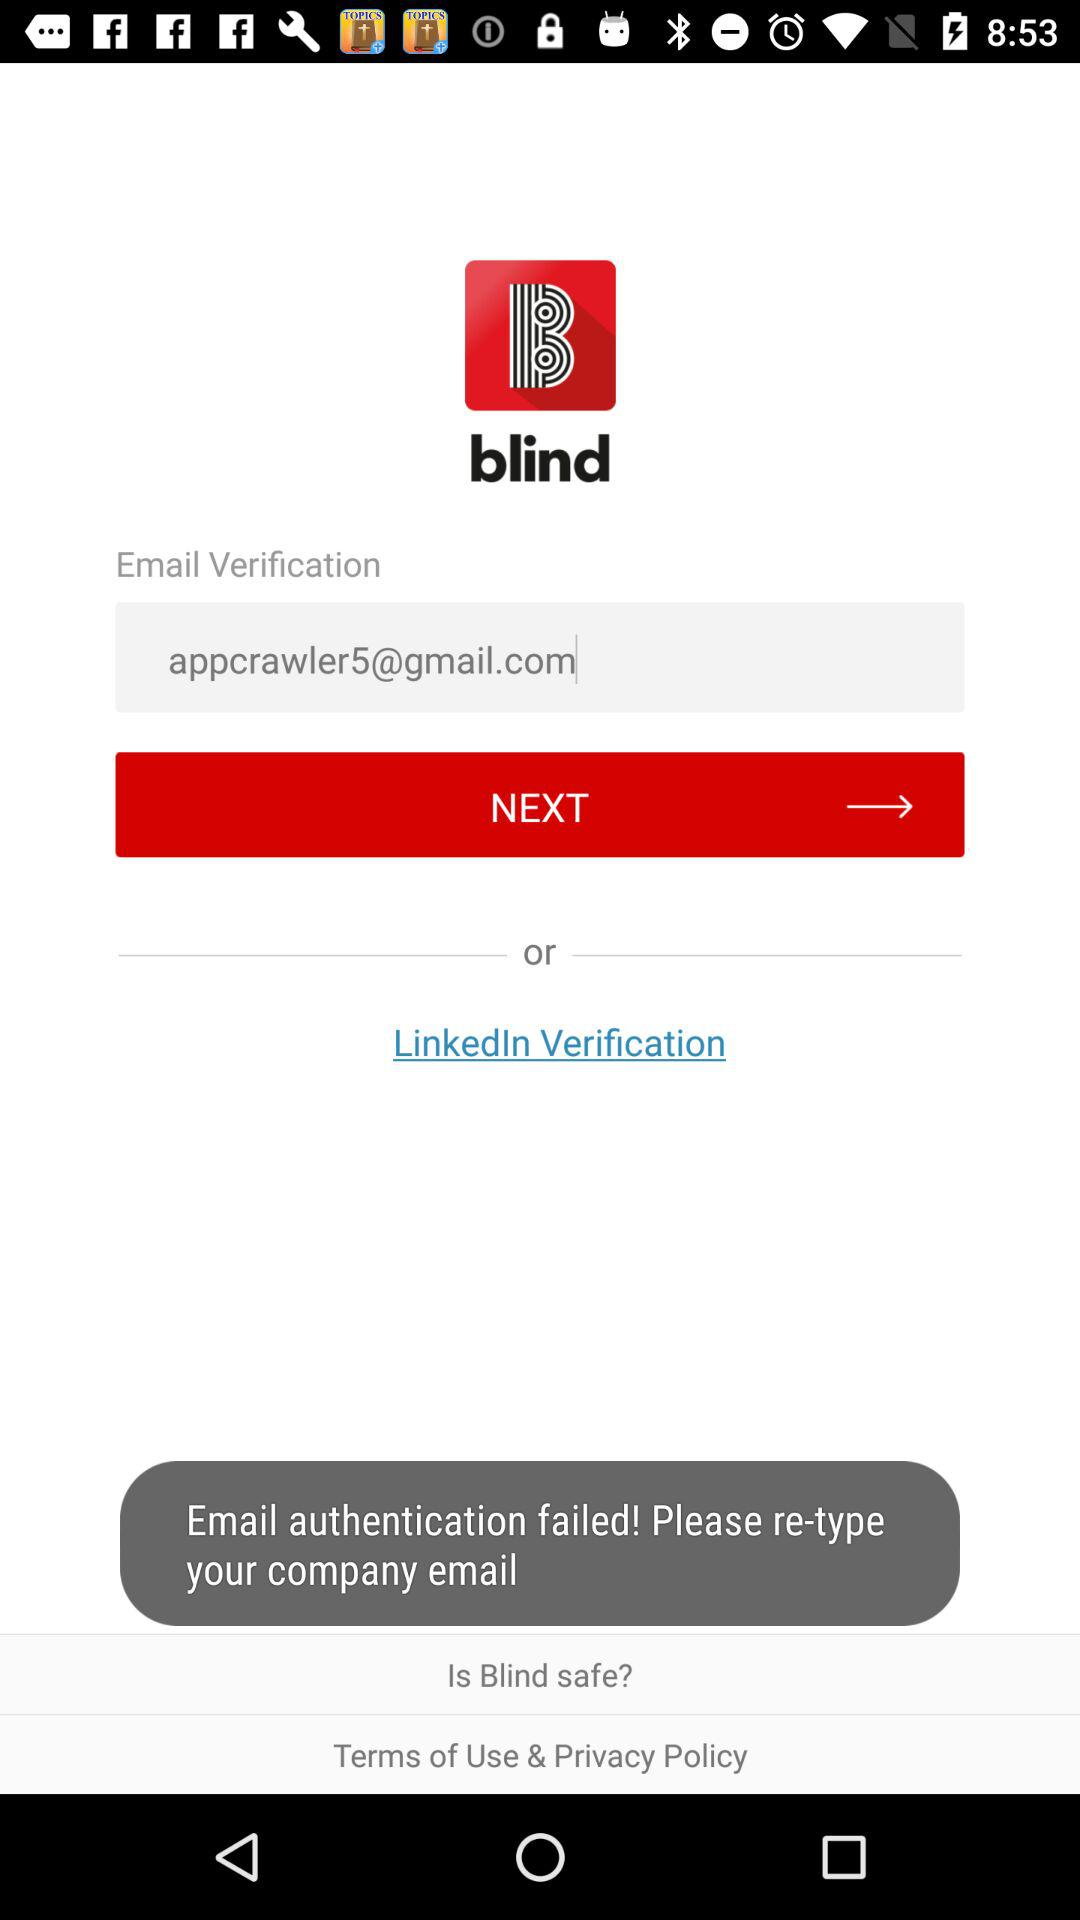What are the two options for verification? The two options for verification are "Email" and "LinkedIn". 